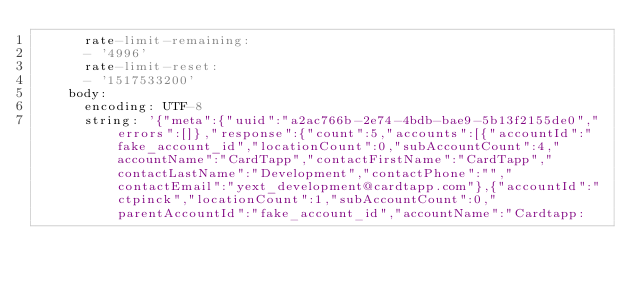Convert code to text. <code><loc_0><loc_0><loc_500><loc_500><_YAML_>      rate-limit-remaining:
      - '4996'
      rate-limit-reset:
      - '1517533200'
    body:
      encoding: UTF-8
      string: '{"meta":{"uuid":"a2ac766b-2e74-4bdb-bae9-5b13f2155de0","errors":[]},"response":{"count":5,"accounts":[{"accountId":"fake_account_id","locationCount":0,"subAccountCount":4,"accountName":"CardTapp","contactFirstName":"CardTapp","contactLastName":"Development","contactPhone":"","contactEmail":"yext_development@cardtapp.com"},{"accountId":"ctpinck","locationCount":1,"subAccountCount":0,"parentAccountId":"fake_account_id","accountName":"Cardtapp:</code> 